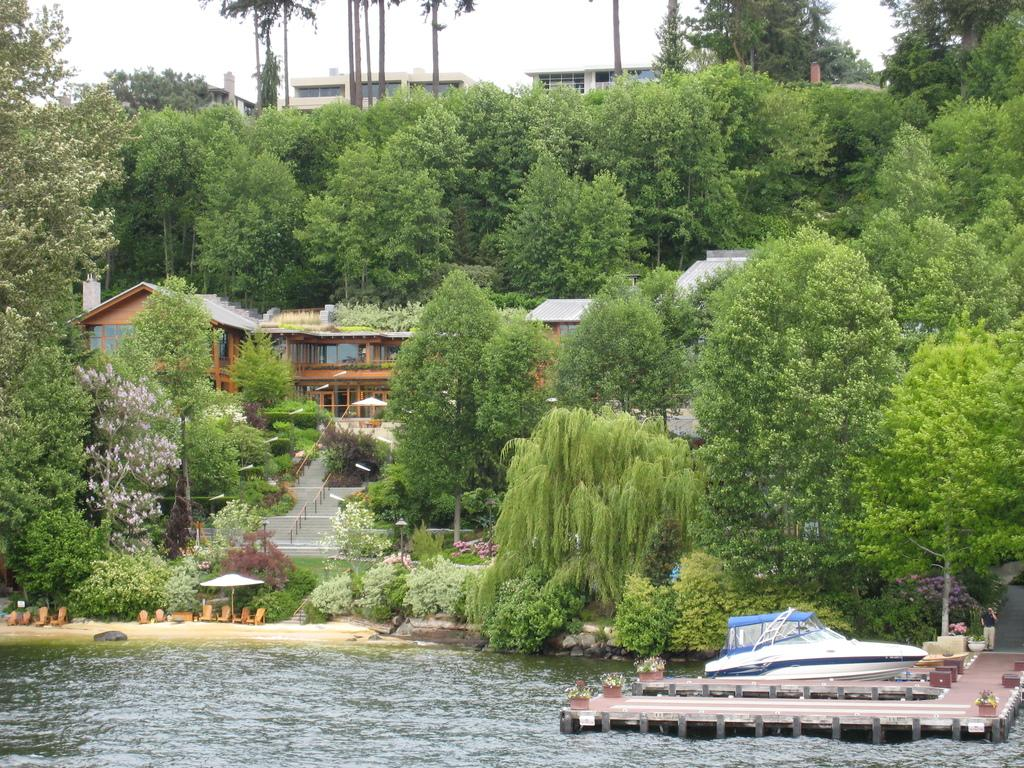What can be seen in the center of the image? The sky is visible in the center of the image. What type of natural elements are present in the image? There are trees in the image. What type of man-made structures can be seen in the image? There are buildings in the image. What body of water is present in the image? There is water in the image. What type of vehicle is in the image? There is a boat in the image. What type of shade structure is in the image? There is an outdoor umbrella in the image. What type of walkway is in the image? There is a wooden pier in the image. How many people are visible in the image? One person is standing in the image. Can you describe any other objects in the image? There are a few other objects in the image. What type of train can be seen passing by in the image? There is no train present in the image. What type of cooking equipment can be seen on the wooden pier in the image? There is no cooking equipment visible in the image. 